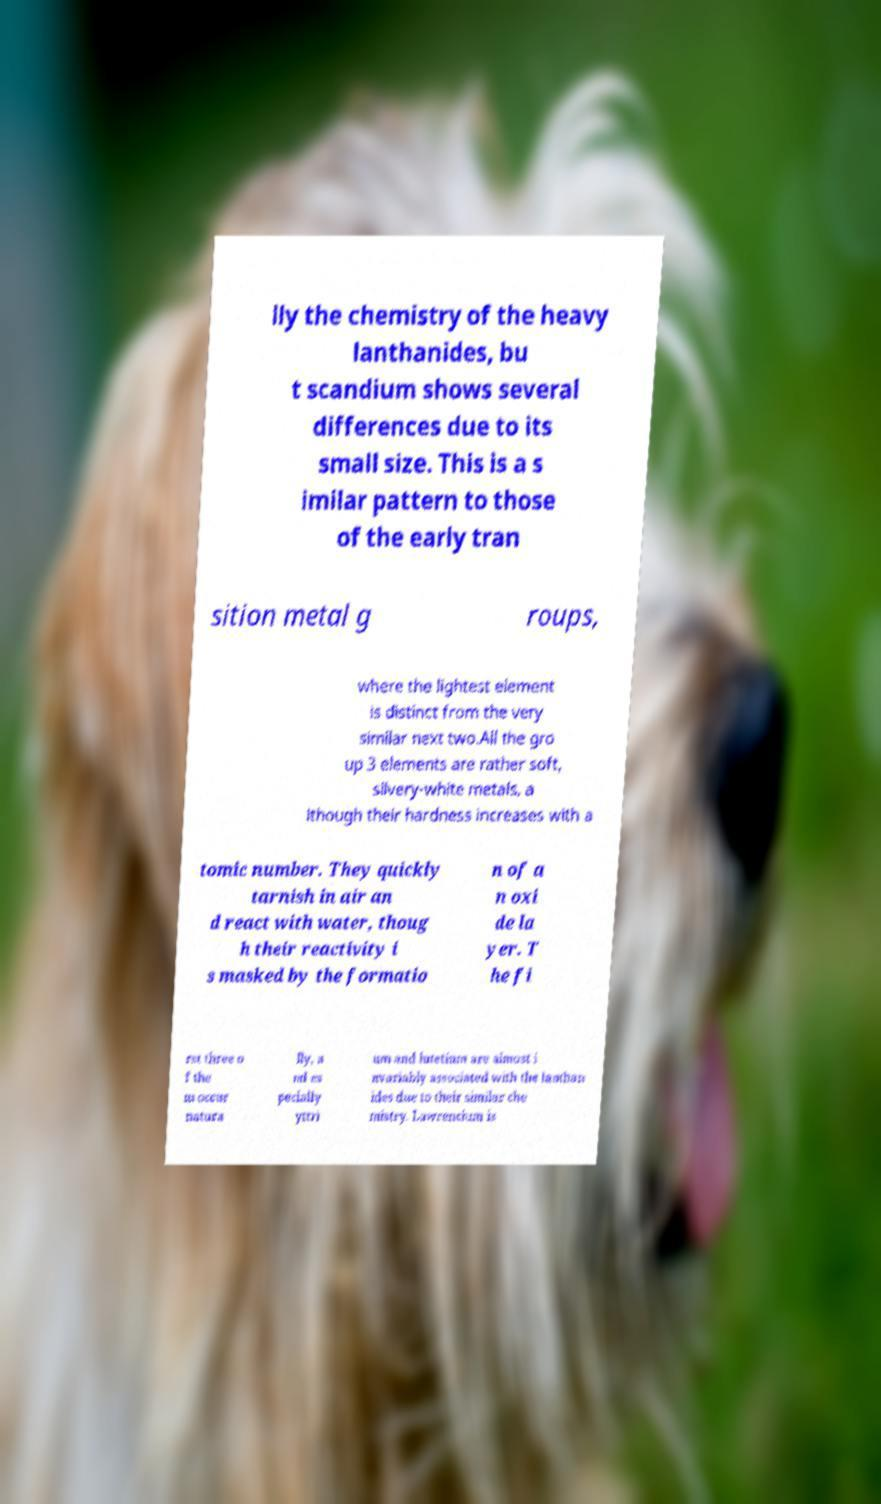Can you read and provide the text displayed in the image?This photo seems to have some interesting text. Can you extract and type it out for me? lly the chemistry of the heavy lanthanides, bu t scandium shows several differences due to its small size. This is a s imilar pattern to those of the early tran sition metal g roups, where the lightest element is distinct from the very similar next two.All the gro up 3 elements are rather soft, silvery-white metals, a lthough their hardness increases with a tomic number. They quickly tarnish in air an d react with water, thoug h their reactivity i s masked by the formatio n of a n oxi de la yer. T he fi rst three o f the m occur natura lly, a nd es pecially yttri um and lutetium are almost i nvariably associated with the lanthan ides due to their similar che mistry. Lawrencium is 